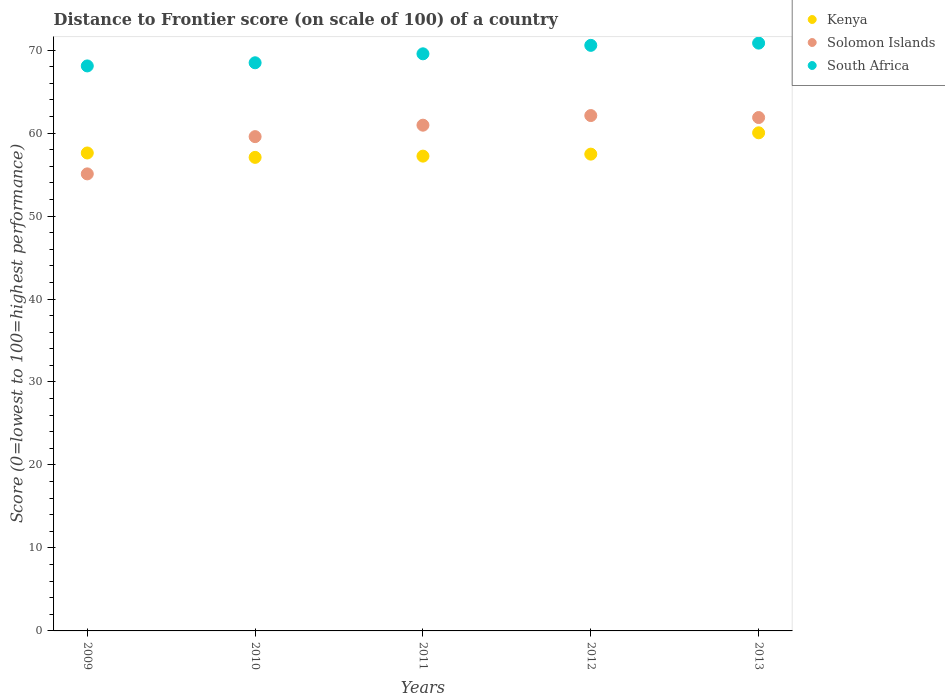How many different coloured dotlines are there?
Keep it short and to the point. 3. Is the number of dotlines equal to the number of legend labels?
Keep it short and to the point. Yes. What is the distance to frontier score of in Kenya in 2011?
Provide a short and direct response. 57.22. Across all years, what is the maximum distance to frontier score of in Solomon Islands?
Offer a very short reply. 62.11. Across all years, what is the minimum distance to frontier score of in South Africa?
Give a very brief answer. 68.09. In which year was the distance to frontier score of in Kenya maximum?
Your answer should be very brief. 2013. In which year was the distance to frontier score of in Kenya minimum?
Ensure brevity in your answer.  2010. What is the total distance to frontier score of in Solomon Islands in the graph?
Your answer should be very brief. 299.58. What is the difference between the distance to frontier score of in Kenya in 2011 and that in 2012?
Your answer should be very brief. -0.24. What is the difference between the distance to frontier score of in South Africa in 2011 and the distance to frontier score of in Kenya in 2013?
Keep it short and to the point. 9.52. What is the average distance to frontier score of in Kenya per year?
Keep it short and to the point. 57.88. In the year 2010, what is the difference between the distance to frontier score of in Kenya and distance to frontier score of in Solomon Islands?
Provide a succinct answer. -2.5. What is the ratio of the distance to frontier score of in South Africa in 2011 to that in 2012?
Keep it short and to the point. 0.99. Is the difference between the distance to frontier score of in Kenya in 2012 and 2013 greater than the difference between the distance to frontier score of in Solomon Islands in 2012 and 2013?
Give a very brief answer. No. What is the difference between the highest and the second highest distance to frontier score of in South Africa?
Offer a terse response. 0.27. What is the difference between the highest and the lowest distance to frontier score of in Kenya?
Your answer should be very brief. 2.96. In how many years, is the distance to frontier score of in Kenya greater than the average distance to frontier score of in Kenya taken over all years?
Provide a short and direct response. 1. Is the sum of the distance to frontier score of in Solomon Islands in 2012 and 2013 greater than the maximum distance to frontier score of in South Africa across all years?
Provide a short and direct response. Yes. Is the distance to frontier score of in Solomon Islands strictly greater than the distance to frontier score of in Kenya over the years?
Your answer should be very brief. No. Is the distance to frontier score of in Kenya strictly less than the distance to frontier score of in South Africa over the years?
Your response must be concise. Yes. What is the difference between two consecutive major ticks on the Y-axis?
Make the answer very short. 10. Are the values on the major ticks of Y-axis written in scientific E-notation?
Provide a succinct answer. No. Does the graph contain any zero values?
Offer a terse response. No. Does the graph contain grids?
Make the answer very short. No. Where does the legend appear in the graph?
Your answer should be compact. Top right. How many legend labels are there?
Offer a terse response. 3. What is the title of the graph?
Make the answer very short. Distance to Frontier score (on scale of 100) of a country. Does "Kosovo" appear as one of the legend labels in the graph?
Ensure brevity in your answer.  No. What is the label or title of the Y-axis?
Provide a succinct answer. Score (0=lowest to 100=highest performance). What is the Score (0=lowest to 100=highest performance) of Kenya in 2009?
Offer a terse response. 57.6. What is the Score (0=lowest to 100=highest performance) of Solomon Islands in 2009?
Keep it short and to the point. 55.08. What is the Score (0=lowest to 100=highest performance) in South Africa in 2009?
Provide a succinct answer. 68.09. What is the Score (0=lowest to 100=highest performance) in Kenya in 2010?
Offer a very short reply. 57.07. What is the Score (0=lowest to 100=highest performance) in Solomon Islands in 2010?
Provide a short and direct response. 59.57. What is the Score (0=lowest to 100=highest performance) in South Africa in 2010?
Your response must be concise. 68.47. What is the Score (0=lowest to 100=highest performance) of Kenya in 2011?
Offer a very short reply. 57.22. What is the Score (0=lowest to 100=highest performance) in Solomon Islands in 2011?
Keep it short and to the point. 60.95. What is the Score (0=lowest to 100=highest performance) in South Africa in 2011?
Ensure brevity in your answer.  69.55. What is the Score (0=lowest to 100=highest performance) of Kenya in 2012?
Your response must be concise. 57.46. What is the Score (0=lowest to 100=highest performance) in Solomon Islands in 2012?
Provide a succinct answer. 62.11. What is the Score (0=lowest to 100=highest performance) of South Africa in 2012?
Your answer should be very brief. 70.57. What is the Score (0=lowest to 100=highest performance) in Kenya in 2013?
Make the answer very short. 60.03. What is the Score (0=lowest to 100=highest performance) of Solomon Islands in 2013?
Keep it short and to the point. 61.87. What is the Score (0=lowest to 100=highest performance) of South Africa in 2013?
Ensure brevity in your answer.  70.84. Across all years, what is the maximum Score (0=lowest to 100=highest performance) in Kenya?
Provide a short and direct response. 60.03. Across all years, what is the maximum Score (0=lowest to 100=highest performance) of Solomon Islands?
Offer a very short reply. 62.11. Across all years, what is the maximum Score (0=lowest to 100=highest performance) in South Africa?
Your answer should be very brief. 70.84. Across all years, what is the minimum Score (0=lowest to 100=highest performance) of Kenya?
Your answer should be compact. 57.07. Across all years, what is the minimum Score (0=lowest to 100=highest performance) in Solomon Islands?
Provide a short and direct response. 55.08. Across all years, what is the minimum Score (0=lowest to 100=highest performance) in South Africa?
Give a very brief answer. 68.09. What is the total Score (0=lowest to 100=highest performance) in Kenya in the graph?
Make the answer very short. 289.38. What is the total Score (0=lowest to 100=highest performance) of Solomon Islands in the graph?
Your answer should be very brief. 299.58. What is the total Score (0=lowest to 100=highest performance) of South Africa in the graph?
Make the answer very short. 347.52. What is the difference between the Score (0=lowest to 100=highest performance) in Kenya in 2009 and that in 2010?
Offer a terse response. 0.53. What is the difference between the Score (0=lowest to 100=highest performance) of Solomon Islands in 2009 and that in 2010?
Ensure brevity in your answer.  -4.49. What is the difference between the Score (0=lowest to 100=highest performance) in South Africa in 2009 and that in 2010?
Ensure brevity in your answer.  -0.38. What is the difference between the Score (0=lowest to 100=highest performance) of Kenya in 2009 and that in 2011?
Give a very brief answer. 0.38. What is the difference between the Score (0=lowest to 100=highest performance) of Solomon Islands in 2009 and that in 2011?
Provide a short and direct response. -5.87. What is the difference between the Score (0=lowest to 100=highest performance) in South Africa in 2009 and that in 2011?
Give a very brief answer. -1.46. What is the difference between the Score (0=lowest to 100=highest performance) in Kenya in 2009 and that in 2012?
Give a very brief answer. 0.14. What is the difference between the Score (0=lowest to 100=highest performance) of Solomon Islands in 2009 and that in 2012?
Your response must be concise. -7.03. What is the difference between the Score (0=lowest to 100=highest performance) in South Africa in 2009 and that in 2012?
Ensure brevity in your answer.  -2.48. What is the difference between the Score (0=lowest to 100=highest performance) in Kenya in 2009 and that in 2013?
Provide a short and direct response. -2.43. What is the difference between the Score (0=lowest to 100=highest performance) in Solomon Islands in 2009 and that in 2013?
Your answer should be compact. -6.79. What is the difference between the Score (0=lowest to 100=highest performance) of South Africa in 2009 and that in 2013?
Provide a succinct answer. -2.75. What is the difference between the Score (0=lowest to 100=highest performance) of Solomon Islands in 2010 and that in 2011?
Make the answer very short. -1.38. What is the difference between the Score (0=lowest to 100=highest performance) of South Africa in 2010 and that in 2011?
Your answer should be compact. -1.08. What is the difference between the Score (0=lowest to 100=highest performance) of Kenya in 2010 and that in 2012?
Make the answer very short. -0.39. What is the difference between the Score (0=lowest to 100=highest performance) in Solomon Islands in 2010 and that in 2012?
Provide a short and direct response. -2.54. What is the difference between the Score (0=lowest to 100=highest performance) of South Africa in 2010 and that in 2012?
Give a very brief answer. -2.1. What is the difference between the Score (0=lowest to 100=highest performance) in Kenya in 2010 and that in 2013?
Provide a succinct answer. -2.96. What is the difference between the Score (0=lowest to 100=highest performance) in South Africa in 2010 and that in 2013?
Provide a succinct answer. -2.37. What is the difference between the Score (0=lowest to 100=highest performance) in Kenya in 2011 and that in 2012?
Make the answer very short. -0.24. What is the difference between the Score (0=lowest to 100=highest performance) of Solomon Islands in 2011 and that in 2012?
Offer a very short reply. -1.16. What is the difference between the Score (0=lowest to 100=highest performance) of South Africa in 2011 and that in 2012?
Offer a terse response. -1.02. What is the difference between the Score (0=lowest to 100=highest performance) in Kenya in 2011 and that in 2013?
Offer a very short reply. -2.81. What is the difference between the Score (0=lowest to 100=highest performance) of Solomon Islands in 2011 and that in 2013?
Ensure brevity in your answer.  -0.92. What is the difference between the Score (0=lowest to 100=highest performance) in South Africa in 2011 and that in 2013?
Your answer should be compact. -1.29. What is the difference between the Score (0=lowest to 100=highest performance) in Kenya in 2012 and that in 2013?
Offer a very short reply. -2.57. What is the difference between the Score (0=lowest to 100=highest performance) in Solomon Islands in 2012 and that in 2013?
Offer a terse response. 0.24. What is the difference between the Score (0=lowest to 100=highest performance) in South Africa in 2012 and that in 2013?
Your response must be concise. -0.27. What is the difference between the Score (0=lowest to 100=highest performance) in Kenya in 2009 and the Score (0=lowest to 100=highest performance) in Solomon Islands in 2010?
Offer a terse response. -1.97. What is the difference between the Score (0=lowest to 100=highest performance) of Kenya in 2009 and the Score (0=lowest to 100=highest performance) of South Africa in 2010?
Offer a very short reply. -10.87. What is the difference between the Score (0=lowest to 100=highest performance) in Solomon Islands in 2009 and the Score (0=lowest to 100=highest performance) in South Africa in 2010?
Provide a succinct answer. -13.39. What is the difference between the Score (0=lowest to 100=highest performance) of Kenya in 2009 and the Score (0=lowest to 100=highest performance) of Solomon Islands in 2011?
Provide a short and direct response. -3.35. What is the difference between the Score (0=lowest to 100=highest performance) of Kenya in 2009 and the Score (0=lowest to 100=highest performance) of South Africa in 2011?
Ensure brevity in your answer.  -11.95. What is the difference between the Score (0=lowest to 100=highest performance) in Solomon Islands in 2009 and the Score (0=lowest to 100=highest performance) in South Africa in 2011?
Your answer should be very brief. -14.47. What is the difference between the Score (0=lowest to 100=highest performance) of Kenya in 2009 and the Score (0=lowest to 100=highest performance) of Solomon Islands in 2012?
Make the answer very short. -4.51. What is the difference between the Score (0=lowest to 100=highest performance) in Kenya in 2009 and the Score (0=lowest to 100=highest performance) in South Africa in 2012?
Ensure brevity in your answer.  -12.97. What is the difference between the Score (0=lowest to 100=highest performance) of Solomon Islands in 2009 and the Score (0=lowest to 100=highest performance) of South Africa in 2012?
Offer a terse response. -15.49. What is the difference between the Score (0=lowest to 100=highest performance) in Kenya in 2009 and the Score (0=lowest to 100=highest performance) in Solomon Islands in 2013?
Your answer should be compact. -4.27. What is the difference between the Score (0=lowest to 100=highest performance) of Kenya in 2009 and the Score (0=lowest to 100=highest performance) of South Africa in 2013?
Give a very brief answer. -13.24. What is the difference between the Score (0=lowest to 100=highest performance) in Solomon Islands in 2009 and the Score (0=lowest to 100=highest performance) in South Africa in 2013?
Your response must be concise. -15.76. What is the difference between the Score (0=lowest to 100=highest performance) in Kenya in 2010 and the Score (0=lowest to 100=highest performance) in Solomon Islands in 2011?
Your answer should be very brief. -3.88. What is the difference between the Score (0=lowest to 100=highest performance) in Kenya in 2010 and the Score (0=lowest to 100=highest performance) in South Africa in 2011?
Offer a very short reply. -12.48. What is the difference between the Score (0=lowest to 100=highest performance) of Solomon Islands in 2010 and the Score (0=lowest to 100=highest performance) of South Africa in 2011?
Your answer should be very brief. -9.98. What is the difference between the Score (0=lowest to 100=highest performance) in Kenya in 2010 and the Score (0=lowest to 100=highest performance) in Solomon Islands in 2012?
Provide a short and direct response. -5.04. What is the difference between the Score (0=lowest to 100=highest performance) in Solomon Islands in 2010 and the Score (0=lowest to 100=highest performance) in South Africa in 2012?
Make the answer very short. -11. What is the difference between the Score (0=lowest to 100=highest performance) in Kenya in 2010 and the Score (0=lowest to 100=highest performance) in South Africa in 2013?
Make the answer very short. -13.77. What is the difference between the Score (0=lowest to 100=highest performance) in Solomon Islands in 2010 and the Score (0=lowest to 100=highest performance) in South Africa in 2013?
Give a very brief answer. -11.27. What is the difference between the Score (0=lowest to 100=highest performance) in Kenya in 2011 and the Score (0=lowest to 100=highest performance) in Solomon Islands in 2012?
Offer a very short reply. -4.89. What is the difference between the Score (0=lowest to 100=highest performance) of Kenya in 2011 and the Score (0=lowest to 100=highest performance) of South Africa in 2012?
Make the answer very short. -13.35. What is the difference between the Score (0=lowest to 100=highest performance) in Solomon Islands in 2011 and the Score (0=lowest to 100=highest performance) in South Africa in 2012?
Ensure brevity in your answer.  -9.62. What is the difference between the Score (0=lowest to 100=highest performance) of Kenya in 2011 and the Score (0=lowest to 100=highest performance) of Solomon Islands in 2013?
Your answer should be very brief. -4.65. What is the difference between the Score (0=lowest to 100=highest performance) of Kenya in 2011 and the Score (0=lowest to 100=highest performance) of South Africa in 2013?
Ensure brevity in your answer.  -13.62. What is the difference between the Score (0=lowest to 100=highest performance) in Solomon Islands in 2011 and the Score (0=lowest to 100=highest performance) in South Africa in 2013?
Your response must be concise. -9.89. What is the difference between the Score (0=lowest to 100=highest performance) of Kenya in 2012 and the Score (0=lowest to 100=highest performance) of Solomon Islands in 2013?
Make the answer very short. -4.41. What is the difference between the Score (0=lowest to 100=highest performance) of Kenya in 2012 and the Score (0=lowest to 100=highest performance) of South Africa in 2013?
Offer a terse response. -13.38. What is the difference between the Score (0=lowest to 100=highest performance) of Solomon Islands in 2012 and the Score (0=lowest to 100=highest performance) of South Africa in 2013?
Provide a short and direct response. -8.73. What is the average Score (0=lowest to 100=highest performance) of Kenya per year?
Your answer should be compact. 57.88. What is the average Score (0=lowest to 100=highest performance) in Solomon Islands per year?
Make the answer very short. 59.92. What is the average Score (0=lowest to 100=highest performance) in South Africa per year?
Give a very brief answer. 69.5. In the year 2009, what is the difference between the Score (0=lowest to 100=highest performance) of Kenya and Score (0=lowest to 100=highest performance) of Solomon Islands?
Offer a terse response. 2.52. In the year 2009, what is the difference between the Score (0=lowest to 100=highest performance) of Kenya and Score (0=lowest to 100=highest performance) of South Africa?
Your response must be concise. -10.49. In the year 2009, what is the difference between the Score (0=lowest to 100=highest performance) in Solomon Islands and Score (0=lowest to 100=highest performance) in South Africa?
Your answer should be compact. -13.01. In the year 2010, what is the difference between the Score (0=lowest to 100=highest performance) of Kenya and Score (0=lowest to 100=highest performance) of South Africa?
Your answer should be very brief. -11.4. In the year 2011, what is the difference between the Score (0=lowest to 100=highest performance) in Kenya and Score (0=lowest to 100=highest performance) in Solomon Islands?
Offer a terse response. -3.73. In the year 2011, what is the difference between the Score (0=lowest to 100=highest performance) in Kenya and Score (0=lowest to 100=highest performance) in South Africa?
Offer a very short reply. -12.33. In the year 2012, what is the difference between the Score (0=lowest to 100=highest performance) in Kenya and Score (0=lowest to 100=highest performance) in Solomon Islands?
Provide a short and direct response. -4.65. In the year 2012, what is the difference between the Score (0=lowest to 100=highest performance) in Kenya and Score (0=lowest to 100=highest performance) in South Africa?
Ensure brevity in your answer.  -13.11. In the year 2012, what is the difference between the Score (0=lowest to 100=highest performance) of Solomon Islands and Score (0=lowest to 100=highest performance) of South Africa?
Offer a very short reply. -8.46. In the year 2013, what is the difference between the Score (0=lowest to 100=highest performance) in Kenya and Score (0=lowest to 100=highest performance) in Solomon Islands?
Provide a succinct answer. -1.84. In the year 2013, what is the difference between the Score (0=lowest to 100=highest performance) of Kenya and Score (0=lowest to 100=highest performance) of South Africa?
Provide a short and direct response. -10.81. In the year 2013, what is the difference between the Score (0=lowest to 100=highest performance) in Solomon Islands and Score (0=lowest to 100=highest performance) in South Africa?
Your answer should be compact. -8.97. What is the ratio of the Score (0=lowest to 100=highest performance) of Kenya in 2009 to that in 2010?
Your response must be concise. 1.01. What is the ratio of the Score (0=lowest to 100=highest performance) of Solomon Islands in 2009 to that in 2010?
Provide a succinct answer. 0.92. What is the ratio of the Score (0=lowest to 100=highest performance) of Kenya in 2009 to that in 2011?
Make the answer very short. 1.01. What is the ratio of the Score (0=lowest to 100=highest performance) in Solomon Islands in 2009 to that in 2011?
Your response must be concise. 0.9. What is the ratio of the Score (0=lowest to 100=highest performance) in Solomon Islands in 2009 to that in 2012?
Make the answer very short. 0.89. What is the ratio of the Score (0=lowest to 100=highest performance) in South Africa in 2009 to that in 2012?
Provide a succinct answer. 0.96. What is the ratio of the Score (0=lowest to 100=highest performance) in Kenya in 2009 to that in 2013?
Offer a very short reply. 0.96. What is the ratio of the Score (0=lowest to 100=highest performance) in Solomon Islands in 2009 to that in 2013?
Make the answer very short. 0.89. What is the ratio of the Score (0=lowest to 100=highest performance) in South Africa in 2009 to that in 2013?
Keep it short and to the point. 0.96. What is the ratio of the Score (0=lowest to 100=highest performance) in Kenya in 2010 to that in 2011?
Your answer should be very brief. 1. What is the ratio of the Score (0=lowest to 100=highest performance) in Solomon Islands in 2010 to that in 2011?
Keep it short and to the point. 0.98. What is the ratio of the Score (0=lowest to 100=highest performance) of South Africa in 2010 to that in 2011?
Offer a terse response. 0.98. What is the ratio of the Score (0=lowest to 100=highest performance) in Solomon Islands in 2010 to that in 2012?
Ensure brevity in your answer.  0.96. What is the ratio of the Score (0=lowest to 100=highest performance) of South Africa in 2010 to that in 2012?
Provide a short and direct response. 0.97. What is the ratio of the Score (0=lowest to 100=highest performance) in Kenya in 2010 to that in 2013?
Make the answer very short. 0.95. What is the ratio of the Score (0=lowest to 100=highest performance) in Solomon Islands in 2010 to that in 2013?
Give a very brief answer. 0.96. What is the ratio of the Score (0=lowest to 100=highest performance) in South Africa in 2010 to that in 2013?
Your answer should be very brief. 0.97. What is the ratio of the Score (0=lowest to 100=highest performance) of Kenya in 2011 to that in 2012?
Keep it short and to the point. 1. What is the ratio of the Score (0=lowest to 100=highest performance) in Solomon Islands in 2011 to that in 2012?
Make the answer very short. 0.98. What is the ratio of the Score (0=lowest to 100=highest performance) of South Africa in 2011 to that in 2012?
Provide a succinct answer. 0.99. What is the ratio of the Score (0=lowest to 100=highest performance) of Kenya in 2011 to that in 2013?
Keep it short and to the point. 0.95. What is the ratio of the Score (0=lowest to 100=highest performance) of Solomon Islands in 2011 to that in 2013?
Provide a short and direct response. 0.99. What is the ratio of the Score (0=lowest to 100=highest performance) in South Africa in 2011 to that in 2013?
Offer a very short reply. 0.98. What is the ratio of the Score (0=lowest to 100=highest performance) of Kenya in 2012 to that in 2013?
Provide a short and direct response. 0.96. What is the difference between the highest and the second highest Score (0=lowest to 100=highest performance) of Kenya?
Provide a succinct answer. 2.43. What is the difference between the highest and the second highest Score (0=lowest to 100=highest performance) of Solomon Islands?
Keep it short and to the point. 0.24. What is the difference between the highest and the second highest Score (0=lowest to 100=highest performance) of South Africa?
Your answer should be very brief. 0.27. What is the difference between the highest and the lowest Score (0=lowest to 100=highest performance) of Kenya?
Provide a succinct answer. 2.96. What is the difference between the highest and the lowest Score (0=lowest to 100=highest performance) in Solomon Islands?
Your answer should be very brief. 7.03. What is the difference between the highest and the lowest Score (0=lowest to 100=highest performance) of South Africa?
Ensure brevity in your answer.  2.75. 